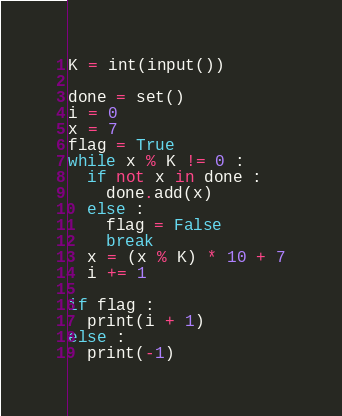<code> <loc_0><loc_0><loc_500><loc_500><_Python_>K = int(input())

done = set()
i = 0
x = 7
flag = True
while x % K != 0 :
  if not x in done :
    done.add(x)
  else :
    flag = False
    break
  x = (x % K) * 10 + 7
  i += 1
    
if flag :
  print(i + 1)
else :
  print(-1)</code> 